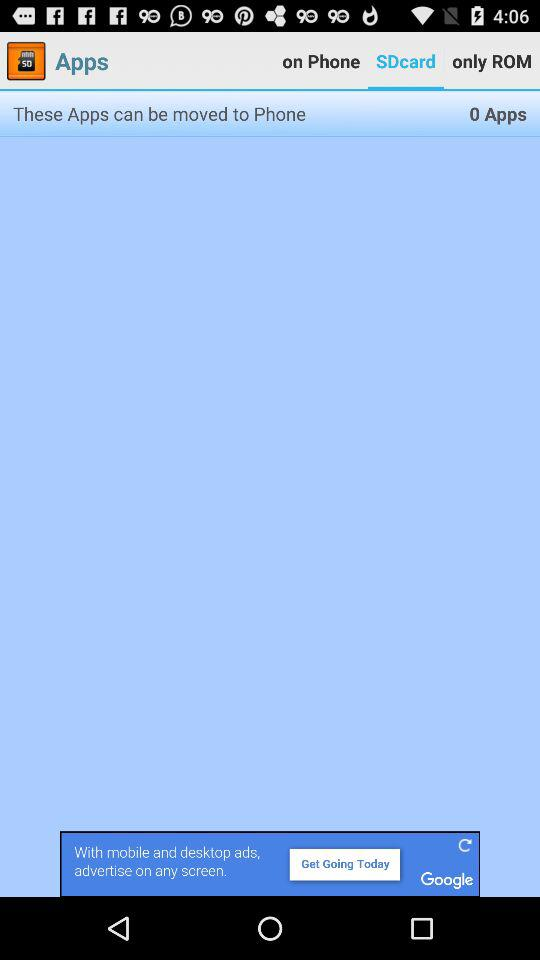How many apps can be moved to Phone?
Answer the question using a single word or phrase. 0 